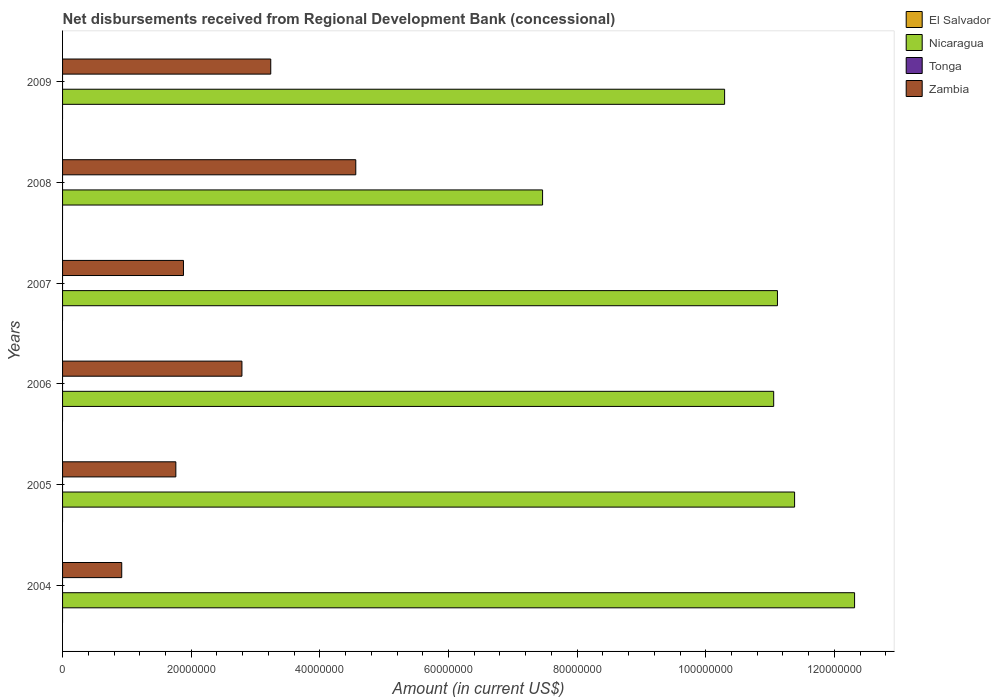Are the number of bars per tick equal to the number of legend labels?
Make the answer very short. No. Are the number of bars on each tick of the Y-axis equal?
Offer a terse response. Yes. What is the label of the 1st group of bars from the top?
Your answer should be compact. 2009. In how many cases, is the number of bars for a given year not equal to the number of legend labels?
Ensure brevity in your answer.  6. What is the amount of disbursements received from Regional Development Bank in Nicaragua in 2007?
Make the answer very short. 1.11e+08. Across all years, what is the maximum amount of disbursements received from Regional Development Bank in Nicaragua?
Your answer should be compact. 1.23e+08. Across all years, what is the minimum amount of disbursements received from Regional Development Bank in Nicaragua?
Give a very brief answer. 7.46e+07. In which year was the amount of disbursements received from Regional Development Bank in Nicaragua maximum?
Give a very brief answer. 2004. What is the total amount of disbursements received from Regional Development Bank in Nicaragua in the graph?
Ensure brevity in your answer.  6.36e+08. What is the difference between the amount of disbursements received from Regional Development Bank in Zambia in 2004 and that in 2007?
Offer a terse response. -9.60e+06. In the year 2005, what is the difference between the amount of disbursements received from Regional Development Bank in Nicaragua and amount of disbursements received from Regional Development Bank in Zambia?
Offer a very short reply. 9.62e+07. What is the ratio of the amount of disbursements received from Regional Development Bank in Nicaragua in 2005 to that in 2008?
Offer a terse response. 1.53. Is the amount of disbursements received from Regional Development Bank in Nicaragua in 2004 less than that in 2005?
Make the answer very short. No. What is the difference between the highest and the second highest amount of disbursements received from Regional Development Bank in Nicaragua?
Give a very brief answer. 9.33e+06. What is the difference between the highest and the lowest amount of disbursements received from Regional Development Bank in Nicaragua?
Your response must be concise. 4.85e+07. In how many years, is the amount of disbursements received from Regional Development Bank in Nicaragua greater than the average amount of disbursements received from Regional Development Bank in Nicaragua taken over all years?
Your answer should be compact. 4. Is the sum of the amount of disbursements received from Regional Development Bank in Nicaragua in 2005 and 2006 greater than the maximum amount of disbursements received from Regional Development Bank in Tonga across all years?
Keep it short and to the point. Yes. Is it the case that in every year, the sum of the amount of disbursements received from Regional Development Bank in Zambia and amount of disbursements received from Regional Development Bank in Nicaragua is greater than the amount of disbursements received from Regional Development Bank in El Salvador?
Provide a succinct answer. Yes. How many bars are there?
Your answer should be very brief. 12. Are all the bars in the graph horizontal?
Ensure brevity in your answer.  Yes. What is the difference between two consecutive major ticks on the X-axis?
Your response must be concise. 2.00e+07. Are the values on the major ticks of X-axis written in scientific E-notation?
Your answer should be compact. No. What is the title of the graph?
Your answer should be compact. Net disbursements received from Regional Development Bank (concessional). Does "Iceland" appear as one of the legend labels in the graph?
Provide a short and direct response. No. What is the label or title of the X-axis?
Offer a very short reply. Amount (in current US$). What is the label or title of the Y-axis?
Your answer should be very brief. Years. What is the Amount (in current US$) in El Salvador in 2004?
Give a very brief answer. 0. What is the Amount (in current US$) in Nicaragua in 2004?
Offer a very short reply. 1.23e+08. What is the Amount (in current US$) in Tonga in 2004?
Make the answer very short. 0. What is the Amount (in current US$) in Zambia in 2004?
Your response must be concise. 9.20e+06. What is the Amount (in current US$) in Nicaragua in 2005?
Keep it short and to the point. 1.14e+08. What is the Amount (in current US$) in Zambia in 2005?
Provide a succinct answer. 1.76e+07. What is the Amount (in current US$) in Nicaragua in 2006?
Provide a short and direct response. 1.11e+08. What is the Amount (in current US$) of Tonga in 2006?
Your response must be concise. 0. What is the Amount (in current US$) of Zambia in 2006?
Keep it short and to the point. 2.79e+07. What is the Amount (in current US$) in El Salvador in 2007?
Ensure brevity in your answer.  0. What is the Amount (in current US$) in Nicaragua in 2007?
Keep it short and to the point. 1.11e+08. What is the Amount (in current US$) of Zambia in 2007?
Provide a short and direct response. 1.88e+07. What is the Amount (in current US$) of El Salvador in 2008?
Your response must be concise. 0. What is the Amount (in current US$) in Nicaragua in 2008?
Provide a succinct answer. 7.46e+07. What is the Amount (in current US$) of Tonga in 2008?
Your response must be concise. 0. What is the Amount (in current US$) in Zambia in 2008?
Your answer should be very brief. 4.56e+07. What is the Amount (in current US$) in Nicaragua in 2009?
Your answer should be very brief. 1.03e+08. What is the Amount (in current US$) of Tonga in 2009?
Your answer should be compact. 0. What is the Amount (in current US$) of Zambia in 2009?
Keep it short and to the point. 3.24e+07. Across all years, what is the maximum Amount (in current US$) in Nicaragua?
Keep it short and to the point. 1.23e+08. Across all years, what is the maximum Amount (in current US$) in Zambia?
Make the answer very short. 4.56e+07. Across all years, what is the minimum Amount (in current US$) of Nicaragua?
Give a very brief answer. 7.46e+07. Across all years, what is the minimum Amount (in current US$) in Zambia?
Offer a very short reply. 9.20e+06. What is the total Amount (in current US$) in Nicaragua in the graph?
Give a very brief answer. 6.36e+08. What is the total Amount (in current US$) of Zambia in the graph?
Keep it short and to the point. 1.51e+08. What is the difference between the Amount (in current US$) of Nicaragua in 2004 and that in 2005?
Keep it short and to the point. 9.33e+06. What is the difference between the Amount (in current US$) in Zambia in 2004 and that in 2005?
Your answer should be compact. -8.41e+06. What is the difference between the Amount (in current US$) in Nicaragua in 2004 and that in 2006?
Offer a terse response. 1.26e+07. What is the difference between the Amount (in current US$) of Zambia in 2004 and that in 2006?
Ensure brevity in your answer.  -1.87e+07. What is the difference between the Amount (in current US$) of Nicaragua in 2004 and that in 2007?
Your answer should be compact. 1.20e+07. What is the difference between the Amount (in current US$) of Zambia in 2004 and that in 2007?
Offer a terse response. -9.60e+06. What is the difference between the Amount (in current US$) in Nicaragua in 2004 and that in 2008?
Offer a terse response. 4.85e+07. What is the difference between the Amount (in current US$) in Zambia in 2004 and that in 2008?
Your answer should be very brief. -3.64e+07. What is the difference between the Amount (in current US$) in Nicaragua in 2004 and that in 2009?
Ensure brevity in your answer.  2.02e+07. What is the difference between the Amount (in current US$) of Zambia in 2004 and that in 2009?
Ensure brevity in your answer.  -2.32e+07. What is the difference between the Amount (in current US$) of Nicaragua in 2005 and that in 2006?
Keep it short and to the point. 3.25e+06. What is the difference between the Amount (in current US$) in Zambia in 2005 and that in 2006?
Your answer should be compact. -1.03e+07. What is the difference between the Amount (in current US$) of Nicaragua in 2005 and that in 2007?
Offer a very short reply. 2.66e+06. What is the difference between the Amount (in current US$) in Zambia in 2005 and that in 2007?
Offer a terse response. -1.18e+06. What is the difference between the Amount (in current US$) of Nicaragua in 2005 and that in 2008?
Your answer should be compact. 3.92e+07. What is the difference between the Amount (in current US$) in Zambia in 2005 and that in 2008?
Your answer should be compact. -2.80e+07. What is the difference between the Amount (in current US$) of Nicaragua in 2005 and that in 2009?
Make the answer very short. 1.09e+07. What is the difference between the Amount (in current US$) in Zambia in 2005 and that in 2009?
Make the answer very short. -1.48e+07. What is the difference between the Amount (in current US$) in Nicaragua in 2006 and that in 2007?
Offer a very short reply. -5.87e+05. What is the difference between the Amount (in current US$) in Zambia in 2006 and that in 2007?
Your response must be concise. 9.09e+06. What is the difference between the Amount (in current US$) of Nicaragua in 2006 and that in 2008?
Make the answer very short. 3.59e+07. What is the difference between the Amount (in current US$) in Zambia in 2006 and that in 2008?
Your answer should be compact. -1.77e+07. What is the difference between the Amount (in current US$) of Nicaragua in 2006 and that in 2009?
Offer a terse response. 7.63e+06. What is the difference between the Amount (in current US$) of Zambia in 2006 and that in 2009?
Give a very brief answer. -4.48e+06. What is the difference between the Amount (in current US$) of Nicaragua in 2007 and that in 2008?
Your response must be concise. 3.65e+07. What is the difference between the Amount (in current US$) in Zambia in 2007 and that in 2008?
Offer a terse response. -2.68e+07. What is the difference between the Amount (in current US$) of Nicaragua in 2007 and that in 2009?
Offer a terse response. 8.22e+06. What is the difference between the Amount (in current US$) in Zambia in 2007 and that in 2009?
Provide a succinct answer. -1.36e+07. What is the difference between the Amount (in current US$) in Nicaragua in 2008 and that in 2009?
Your response must be concise. -2.83e+07. What is the difference between the Amount (in current US$) of Zambia in 2008 and that in 2009?
Provide a succinct answer. 1.32e+07. What is the difference between the Amount (in current US$) in Nicaragua in 2004 and the Amount (in current US$) in Zambia in 2005?
Make the answer very short. 1.06e+08. What is the difference between the Amount (in current US$) in Nicaragua in 2004 and the Amount (in current US$) in Zambia in 2006?
Keep it short and to the point. 9.53e+07. What is the difference between the Amount (in current US$) in Nicaragua in 2004 and the Amount (in current US$) in Zambia in 2007?
Keep it short and to the point. 1.04e+08. What is the difference between the Amount (in current US$) of Nicaragua in 2004 and the Amount (in current US$) of Zambia in 2008?
Make the answer very short. 7.76e+07. What is the difference between the Amount (in current US$) in Nicaragua in 2004 and the Amount (in current US$) in Zambia in 2009?
Make the answer very short. 9.08e+07. What is the difference between the Amount (in current US$) in Nicaragua in 2005 and the Amount (in current US$) in Zambia in 2006?
Your answer should be very brief. 8.59e+07. What is the difference between the Amount (in current US$) in Nicaragua in 2005 and the Amount (in current US$) in Zambia in 2007?
Offer a very short reply. 9.50e+07. What is the difference between the Amount (in current US$) in Nicaragua in 2005 and the Amount (in current US$) in Zambia in 2008?
Offer a very short reply. 6.82e+07. What is the difference between the Amount (in current US$) in Nicaragua in 2005 and the Amount (in current US$) in Zambia in 2009?
Make the answer very short. 8.14e+07. What is the difference between the Amount (in current US$) of Nicaragua in 2006 and the Amount (in current US$) of Zambia in 2007?
Your answer should be very brief. 9.18e+07. What is the difference between the Amount (in current US$) in Nicaragua in 2006 and the Amount (in current US$) in Zambia in 2008?
Provide a short and direct response. 6.50e+07. What is the difference between the Amount (in current US$) of Nicaragua in 2006 and the Amount (in current US$) of Zambia in 2009?
Keep it short and to the point. 7.82e+07. What is the difference between the Amount (in current US$) in Nicaragua in 2007 and the Amount (in current US$) in Zambia in 2008?
Offer a terse response. 6.56e+07. What is the difference between the Amount (in current US$) in Nicaragua in 2007 and the Amount (in current US$) in Zambia in 2009?
Provide a succinct answer. 7.88e+07. What is the difference between the Amount (in current US$) of Nicaragua in 2008 and the Amount (in current US$) of Zambia in 2009?
Provide a short and direct response. 4.23e+07. What is the average Amount (in current US$) in Nicaragua per year?
Your answer should be compact. 1.06e+08. What is the average Amount (in current US$) of Zambia per year?
Your answer should be compact. 2.52e+07. In the year 2004, what is the difference between the Amount (in current US$) in Nicaragua and Amount (in current US$) in Zambia?
Offer a terse response. 1.14e+08. In the year 2005, what is the difference between the Amount (in current US$) in Nicaragua and Amount (in current US$) in Zambia?
Give a very brief answer. 9.62e+07. In the year 2006, what is the difference between the Amount (in current US$) in Nicaragua and Amount (in current US$) in Zambia?
Your answer should be compact. 8.27e+07. In the year 2007, what is the difference between the Amount (in current US$) in Nicaragua and Amount (in current US$) in Zambia?
Make the answer very short. 9.24e+07. In the year 2008, what is the difference between the Amount (in current US$) in Nicaragua and Amount (in current US$) in Zambia?
Your response must be concise. 2.90e+07. In the year 2009, what is the difference between the Amount (in current US$) of Nicaragua and Amount (in current US$) of Zambia?
Offer a very short reply. 7.06e+07. What is the ratio of the Amount (in current US$) of Nicaragua in 2004 to that in 2005?
Offer a very short reply. 1.08. What is the ratio of the Amount (in current US$) of Zambia in 2004 to that in 2005?
Offer a terse response. 0.52. What is the ratio of the Amount (in current US$) of Nicaragua in 2004 to that in 2006?
Ensure brevity in your answer.  1.11. What is the ratio of the Amount (in current US$) of Zambia in 2004 to that in 2006?
Ensure brevity in your answer.  0.33. What is the ratio of the Amount (in current US$) of Nicaragua in 2004 to that in 2007?
Ensure brevity in your answer.  1.11. What is the ratio of the Amount (in current US$) in Zambia in 2004 to that in 2007?
Keep it short and to the point. 0.49. What is the ratio of the Amount (in current US$) in Nicaragua in 2004 to that in 2008?
Make the answer very short. 1.65. What is the ratio of the Amount (in current US$) in Zambia in 2004 to that in 2008?
Provide a short and direct response. 0.2. What is the ratio of the Amount (in current US$) in Nicaragua in 2004 to that in 2009?
Ensure brevity in your answer.  1.2. What is the ratio of the Amount (in current US$) of Zambia in 2004 to that in 2009?
Your answer should be very brief. 0.28. What is the ratio of the Amount (in current US$) in Nicaragua in 2005 to that in 2006?
Keep it short and to the point. 1.03. What is the ratio of the Amount (in current US$) in Zambia in 2005 to that in 2006?
Your answer should be very brief. 0.63. What is the ratio of the Amount (in current US$) of Nicaragua in 2005 to that in 2007?
Provide a short and direct response. 1.02. What is the ratio of the Amount (in current US$) in Zambia in 2005 to that in 2007?
Your answer should be very brief. 0.94. What is the ratio of the Amount (in current US$) of Nicaragua in 2005 to that in 2008?
Your answer should be compact. 1.52. What is the ratio of the Amount (in current US$) in Zambia in 2005 to that in 2008?
Offer a terse response. 0.39. What is the ratio of the Amount (in current US$) of Nicaragua in 2005 to that in 2009?
Offer a terse response. 1.11. What is the ratio of the Amount (in current US$) of Zambia in 2005 to that in 2009?
Offer a very short reply. 0.54. What is the ratio of the Amount (in current US$) of Zambia in 2006 to that in 2007?
Your response must be concise. 1.48. What is the ratio of the Amount (in current US$) of Nicaragua in 2006 to that in 2008?
Your response must be concise. 1.48. What is the ratio of the Amount (in current US$) in Zambia in 2006 to that in 2008?
Provide a succinct answer. 0.61. What is the ratio of the Amount (in current US$) in Nicaragua in 2006 to that in 2009?
Ensure brevity in your answer.  1.07. What is the ratio of the Amount (in current US$) in Zambia in 2006 to that in 2009?
Your answer should be compact. 0.86. What is the ratio of the Amount (in current US$) of Nicaragua in 2007 to that in 2008?
Offer a terse response. 1.49. What is the ratio of the Amount (in current US$) in Zambia in 2007 to that in 2008?
Your answer should be compact. 0.41. What is the ratio of the Amount (in current US$) of Nicaragua in 2007 to that in 2009?
Ensure brevity in your answer.  1.08. What is the ratio of the Amount (in current US$) of Zambia in 2007 to that in 2009?
Offer a terse response. 0.58. What is the ratio of the Amount (in current US$) of Nicaragua in 2008 to that in 2009?
Ensure brevity in your answer.  0.73. What is the ratio of the Amount (in current US$) of Zambia in 2008 to that in 2009?
Your answer should be very brief. 1.41. What is the difference between the highest and the second highest Amount (in current US$) of Nicaragua?
Offer a very short reply. 9.33e+06. What is the difference between the highest and the second highest Amount (in current US$) in Zambia?
Make the answer very short. 1.32e+07. What is the difference between the highest and the lowest Amount (in current US$) of Nicaragua?
Ensure brevity in your answer.  4.85e+07. What is the difference between the highest and the lowest Amount (in current US$) in Zambia?
Offer a very short reply. 3.64e+07. 